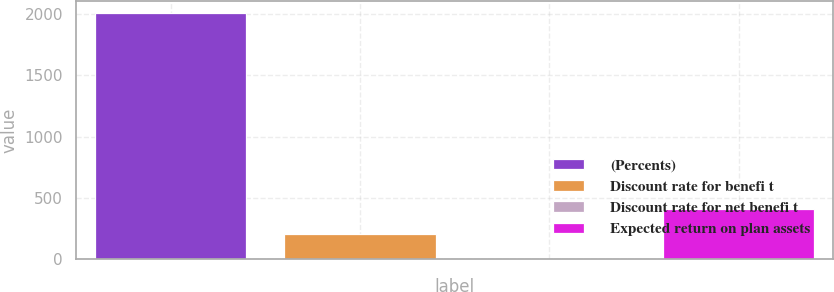<chart> <loc_0><loc_0><loc_500><loc_500><bar_chart><fcel>(Percents)<fcel>Discount rate for benefi t<fcel>Discount rate for net benefi t<fcel>Expected return on plan assets<nl><fcel>2007<fcel>205.83<fcel>5.7<fcel>405.96<nl></chart> 